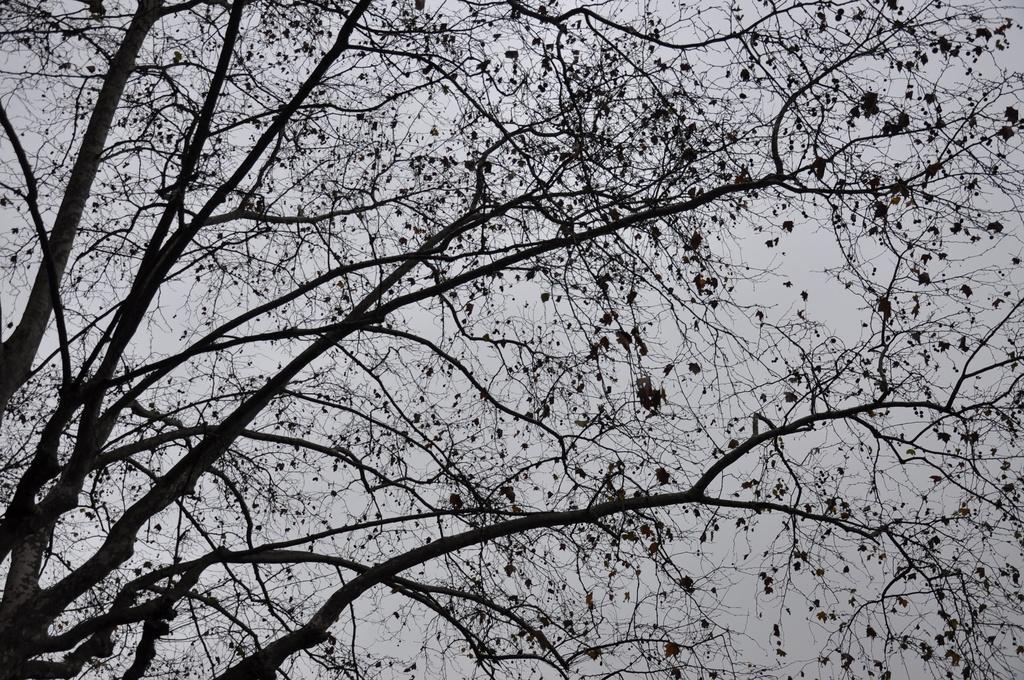Could you give a brief overview of what you see in this image? In this image there is a tree with so many branches and dry leaves. 